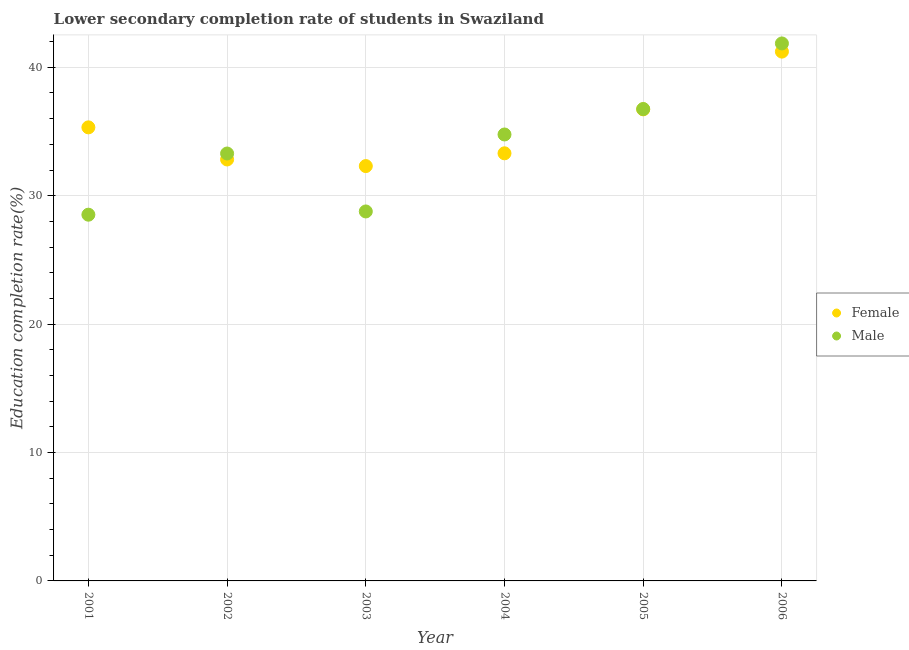How many different coloured dotlines are there?
Offer a terse response. 2. What is the education completion rate of female students in 2005?
Offer a very short reply. 36.73. Across all years, what is the maximum education completion rate of male students?
Ensure brevity in your answer.  41.86. Across all years, what is the minimum education completion rate of female students?
Your response must be concise. 32.31. What is the total education completion rate of female students in the graph?
Your answer should be compact. 211.7. What is the difference between the education completion rate of male students in 2002 and that in 2003?
Your response must be concise. 4.51. What is the difference between the education completion rate of male students in 2003 and the education completion rate of female students in 2001?
Make the answer very short. -6.55. What is the average education completion rate of male students per year?
Give a very brief answer. 33.99. In the year 2004, what is the difference between the education completion rate of female students and education completion rate of male students?
Provide a succinct answer. -1.47. What is the ratio of the education completion rate of female students in 2001 to that in 2004?
Give a very brief answer. 1.06. Is the education completion rate of male students in 2003 less than that in 2004?
Provide a succinct answer. Yes. Is the difference between the education completion rate of male students in 2001 and 2002 greater than the difference between the education completion rate of female students in 2001 and 2002?
Your response must be concise. No. What is the difference between the highest and the second highest education completion rate of female students?
Provide a short and direct response. 4.5. What is the difference between the highest and the lowest education completion rate of female students?
Offer a terse response. 8.91. Is the sum of the education completion rate of male students in 2001 and 2006 greater than the maximum education completion rate of female students across all years?
Ensure brevity in your answer.  Yes. Does the education completion rate of male students monotonically increase over the years?
Ensure brevity in your answer.  No. Is the education completion rate of female students strictly greater than the education completion rate of male students over the years?
Provide a succinct answer. No. Is the education completion rate of female students strictly less than the education completion rate of male students over the years?
Keep it short and to the point. No. How many dotlines are there?
Your response must be concise. 2. How many years are there in the graph?
Your answer should be very brief. 6. What is the difference between two consecutive major ticks on the Y-axis?
Offer a terse response. 10. Are the values on the major ticks of Y-axis written in scientific E-notation?
Provide a short and direct response. No. Does the graph contain any zero values?
Your response must be concise. No. Does the graph contain grids?
Your answer should be compact. Yes. How many legend labels are there?
Provide a short and direct response. 2. What is the title of the graph?
Provide a succinct answer. Lower secondary completion rate of students in Swaziland. Does "Forest" appear as one of the legend labels in the graph?
Provide a succinct answer. No. What is the label or title of the Y-axis?
Your response must be concise. Education completion rate(%). What is the Education completion rate(%) in Female in 2001?
Offer a terse response. 35.32. What is the Education completion rate(%) of Male in 2001?
Make the answer very short. 28.52. What is the Education completion rate(%) in Female in 2002?
Keep it short and to the point. 32.82. What is the Education completion rate(%) of Male in 2002?
Your response must be concise. 33.29. What is the Education completion rate(%) of Female in 2003?
Provide a short and direct response. 32.31. What is the Education completion rate(%) of Male in 2003?
Keep it short and to the point. 28.77. What is the Education completion rate(%) of Female in 2004?
Provide a short and direct response. 33.3. What is the Education completion rate(%) of Male in 2004?
Provide a short and direct response. 34.77. What is the Education completion rate(%) of Female in 2005?
Offer a terse response. 36.73. What is the Education completion rate(%) of Male in 2005?
Offer a very short reply. 36.75. What is the Education completion rate(%) of Female in 2006?
Offer a very short reply. 41.22. What is the Education completion rate(%) in Male in 2006?
Ensure brevity in your answer.  41.86. Across all years, what is the maximum Education completion rate(%) of Female?
Your answer should be very brief. 41.22. Across all years, what is the maximum Education completion rate(%) in Male?
Provide a succinct answer. 41.86. Across all years, what is the minimum Education completion rate(%) of Female?
Your response must be concise. 32.31. Across all years, what is the minimum Education completion rate(%) of Male?
Give a very brief answer. 28.52. What is the total Education completion rate(%) in Female in the graph?
Your response must be concise. 211.7. What is the total Education completion rate(%) in Male in the graph?
Your response must be concise. 203.96. What is the difference between the Education completion rate(%) of Female in 2001 and that in 2002?
Your response must be concise. 2.5. What is the difference between the Education completion rate(%) in Male in 2001 and that in 2002?
Your answer should be compact. -4.76. What is the difference between the Education completion rate(%) in Female in 2001 and that in 2003?
Your response must be concise. 3.02. What is the difference between the Education completion rate(%) in Male in 2001 and that in 2003?
Provide a short and direct response. -0.25. What is the difference between the Education completion rate(%) in Female in 2001 and that in 2004?
Offer a very short reply. 2.02. What is the difference between the Education completion rate(%) in Male in 2001 and that in 2004?
Give a very brief answer. -6.25. What is the difference between the Education completion rate(%) in Female in 2001 and that in 2005?
Make the answer very short. -1.4. What is the difference between the Education completion rate(%) in Male in 2001 and that in 2005?
Offer a terse response. -8.23. What is the difference between the Education completion rate(%) in Female in 2001 and that in 2006?
Provide a succinct answer. -5.9. What is the difference between the Education completion rate(%) of Male in 2001 and that in 2006?
Provide a short and direct response. -13.34. What is the difference between the Education completion rate(%) of Female in 2002 and that in 2003?
Your response must be concise. 0.51. What is the difference between the Education completion rate(%) of Male in 2002 and that in 2003?
Make the answer very short. 4.51. What is the difference between the Education completion rate(%) in Female in 2002 and that in 2004?
Your response must be concise. -0.48. What is the difference between the Education completion rate(%) in Male in 2002 and that in 2004?
Offer a very short reply. -1.48. What is the difference between the Education completion rate(%) in Female in 2002 and that in 2005?
Make the answer very short. -3.9. What is the difference between the Education completion rate(%) in Male in 2002 and that in 2005?
Provide a succinct answer. -3.47. What is the difference between the Education completion rate(%) of Female in 2002 and that in 2006?
Offer a terse response. -8.4. What is the difference between the Education completion rate(%) of Male in 2002 and that in 2006?
Your answer should be compact. -8.57. What is the difference between the Education completion rate(%) in Female in 2003 and that in 2004?
Your response must be concise. -0.99. What is the difference between the Education completion rate(%) in Male in 2003 and that in 2004?
Your answer should be very brief. -5.99. What is the difference between the Education completion rate(%) in Female in 2003 and that in 2005?
Offer a very short reply. -4.42. What is the difference between the Education completion rate(%) in Male in 2003 and that in 2005?
Your answer should be very brief. -7.98. What is the difference between the Education completion rate(%) in Female in 2003 and that in 2006?
Give a very brief answer. -8.91. What is the difference between the Education completion rate(%) in Male in 2003 and that in 2006?
Your response must be concise. -13.08. What is the difference between the Education completion rate(%) of Female in 2004 and that in 2005?
Make the answer very short. -3.42. What is the difference between the Education completion rate(%) in Male in 2004 and that in 2005?
Provide a short and direct response. -1.98. What is the difference between the Education completion rate(%) in Female in 2004 and that in 2006?
Your answer should be compact. -7.92. What is the difference between the Education completion rate(%) of Male in 2004 and that in 2006?
Offer a terse response. -7.09. What is the difference between the Education completion rate(%) of Female in 2005 and that in 2006?
Your answer should be compact. -4.5. What is the difference between the Education completion rate(%) in Male in 2005 and that in 2006?
Provide a short and direct response. -5.11. What is the difference between the Education completion rate(%) of Female in 2001 and the Education completion rate(%) of Male in 2002?
Keep it short and to the point. 2.04. What is the difference between the Education completion rate(%) of Female in 2001 and the Education completion rate(%) of Male in 2003?
Your answer should be compact. 6.55. What is the difference between the Education completion rate(%) of Female in 2001 and the Education completion rate(%) of Male in 2004?
Make the answer very short. 0.55. What is the difference between the Education completion rate(%) of Female in 2001 and the Education completion rate(%) of Male in 2005?
Ensure brevity in your answer.  -1.43. What is the difference between the Education completion rate(%) in Female in 2001 and the Education completion rate(%) in Male in 2006?
Provide a short and direct response. -6.54. What is the difference between the Education completion rate(%) of Female in 2002 and the Education completion rate(%) of Male in 2003?
Your answer should be very brief. 4.05. What is the difference between the Education completion rate(%) in Female in 2002 and the Education completion rate(%) in Male in 2004?
Your answer should be very brief. -1.95. What is the difference between the Education completion rate(%) of Female in 2002 and the Education completion rate(%) of Male in 2005?
Make the answer very short. -3.93. What is the difference between the Education completion rate(%) in Female in 2002 and the Education completion rate(%) in Male in 2006?
Provide a short and direct response. -9.04. What is the difference between the Education completion rate(%) in Female in 2003 and the Education completion rate(%) in Male in 2004?
Your response must be concise. -2.46. What is the difference between the Education completion rate(%) of Female in 2003 and the Education completion rate(%) of Male in 2005?
Give a very brief answer. -4.44. What is the difference between the Education completion rate(%) of Female in 2003 and the Education completion rate(%) of Male in 2006?
Your response must be concise. -9.55. What is the difference between the Education completion rate(%) of Female in 2004 and the Education completion rate(%) of Male in 2005?
Your answer should be very brief. -3.45. What is the difference between the Education completion rate(%) in Female in 2004 and the Education completion rate(%) in Male in 2006?
Keep it short and to the point. -8.56. What is the difference between the Education completion rate(%) in Female in 2005 and the Education completion rate(%) in Male in 2006?
Provide a succinct answer. -5.13. What is the average Education completion rate(%) of Female per year?
Your answer should be very brief. 35.28. What is the average Education completion rate(%) of Male per year?
Offer a terse response. 33.99. In the year 2001, what is the difference between the Education completion rate(%) of Female and Education completion rate(%) of Male?
Your response must be concise. 6.8. In the year 2002, what is the difference between the Education completion rate(%) of Female and Education completion rate(%) of Male?
Provide a succinct answer. -0.46. In the year 2003, what is the difference between the Education completion rate(%) in Female and Education completion rate(%) in Male?
Give a very brief answer. 3.53. In the year 2004, what is the difference between the Education completion rate(%) of Female and Education completion rate(%) of Male?
Your response must be concise. -1.47. In the year 2005, what is the difference between the Education completion rate(%) of Female and Education completion rate(%) of Male?
Provide a succinct answer. -0.03. In the year 2006, what is the difference between the Education completion rate(%) of Female and Education completion rate(%) of Male?
Give a very brief answer. -0.64. What is the ratio of the Education completion rate(%) of Female in 2001 to that in 2002?
Provide a short and direct response. 1.08. What is the ratio of the Education completion rate(%) in Male in 2001 to that in 2002?
Keep it short and to the point. 0.86. What is the ratio of the Education completion rate(%) of Female in 2001 to that in 2003?
Ensure brevity in your answer.  1.09. What is the ratio of the Education completion rate(%) in Male in 2001 to that in 2003?
Give a very brief answer. 0.99. What is the ratio of the Education completion rate(%) in Female in 2001 to that in 2004?
Your response must be concise. 1.06. What is the ratio of the Education completion rate(%) in Male in 2001 to that in 2004?
Provide a succinct answer. 0.82. What is the ratio of the Education completion rate(%) in Female in 2001 to that in 2005?
Keep it short and to the point. 0.96. What is the ratio of the Education completion rate(%) in Male in 2001 to that in 2005?
Your answer should be compact. 0.78. What is the ratio of the Education completion rate(%) in Female in 2001 to that in 2006?
Your response must be concise. 0.86. What is the ratio of the Education completion rate(%) in Male in 2001 to that in 2006?
Your answer should be very brief. 0.68. What is the ratio of the Education completion rate(%) of Female in 2002 to that in 2003?
Offer a terse response. 1.02. What is the ratio of the Education completion rate(%) in Male in 2002 to that in 2003?
Your response must be concise. 1.16. What is the ratio of the Education completion rate(%) of Female in 2002 to that in 2004?
Offer a very short reply. 0.99. What is the ratio of the Education completion rate(%) in Male in 2002 to that in 2004?
Provide a succinct answer. 0.96. What is the ratio of the Education completion rate(%) in Female in 2002 to that in 2005?
Provide a succinct answer. 0.89. What is the ratio of the Education completion rate(%) of Male in 2002 to that in 2005?
Offer a very short reply. 0.91. What is the ratio of the Education completion rate(%) of Female in 2002 to that in 2006?
Provide a short and direct response. 0.8. What is the ratio of the Education completion rate(%) in Male in 2002 to that in 2006?
Offer a very short reply. 0.8. What is the ratio of the Education completion rate(%) of Female in 2003 to that in 2004?
Your response must be concise. 0.97. What is the ratio of the Education completion rate(%) in Male in 2003 to that in 2004?
Your response must be concise. 0.83. What is the ratio of the Education completion rate(%) in Female in 2003 to that in 2005?
Your response must be concise. 0.88. What is the ratio of the Education completion rate(%) of Male in 2003 to that in 2005?
Your answer should be compact. 0.78. What is the ratio of the Education completion rate(%) in Female in 2003 to that in 2006?
Offer a terse response. 0.78. What is the ratio of the Education completion rate(%) in Male in 2003 to that in 2006?
Offer a terse response. 0.69. What is the ratio of the Education completion rate(%) in Female in 2004 to that in 2005?
Offer a very short reply. 0.91. What is the ratio of the Education completion rate(%) of Male in 2004 to that in 2005?
Ensure brevity in your answer.  0.95. What is the ratio of the Education completion rate(%) in Female in 2004 to that in 2006?
Give a very brief answer. 0.81. What is the ratio of the Education completion rate(%) in Male in 2004 to that in 2006?
Give a very brief answer. 0.83. What is the ratio of the Education completion rate(%) of Female in 2005 to that in 2006?
Make the answer very short. 0.89. What is the ratio of the Education completion rate(%) in Male in 2005 to that in 2006?
Offer a very short reply. 0.88. What is the difference between the highest and the second highest Education completion rate(%) in Female?
Your answer should be compact. 4.5. What is the difference between the highest and the second highest Education completion rate(%) of Male?
Provide a short and direct response. 5.11. What is the difference between the highest and the lowest Education completion rate(%) in Female?
Give a very brief answer. 8.91. What is the difference between the highest and the lowest Education completion rate(%) of Male?
Ensure brevity in your answer.  13.34. 